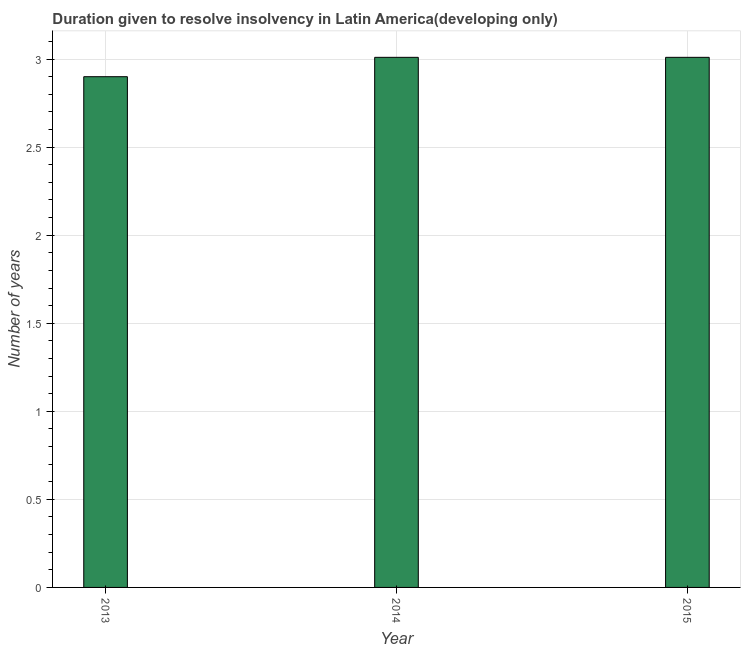Does the graph contain any zero values?
Offer a terse response. No. Does the graph contain grids?
Your answer should be very brief. Yes. What is the title of the graph?
Provide a short and direct response. Duration given to resolve insolvency in Latin America(developing only). What is the label or title of the X-axis?
Provide a succinct answer. Year. What is the label or title of the Y-axis?
Offer a terse response. Number of years. What is the number of years to resolve insolvency in 2013?
Offer a very short reply. 2.9. Across all years, what is the maximum number of years to resolve insolvency?
Your answer should be compact. 3.01. What is the sum of the number of years to resolve insolvency?
Ensure brevity in your answer.  8.92. What is the difference between the number of years to resolve insolvency in 2014 and 2015?
Offer a terse response. 0. What is the average number of years to resolve insolvency per year?
Provide a succinct answer. 2.97. What is the median number of years to resolve insolvency?
Make the answer very short. 3.01. What is the ratio of the number of years to resolve insolvency in 2013 to that in 2015?
Provide a short and direct response. 0.96. Is the difference between the number of years to resolve insolvency in 2013 and 2014 greater than the difference between any two years?
Your response must be concise. Yes. What is the difference between the highest and the second highest number of years to resolve insolvency?
Your answer should be very brief. 0. Is the sum of the number of years to resolve insolvency in 2013 and 2014 greater than the maximum number of years to resolve insolvency across all years?
Provide a succinct answer. Yes. What is the difference between the highest and the lowest number of years to resolve insolvency?
Offer a very short reply. 0.11. How many years are there in the graph?
Offer a terse response. 3. What is the difference between two consecutive major ticks on the Y-axis?
Provide a short and direct response. 0.5. What is the Number of years of 2013?
Offer a terse response. 2.9. What is the Number of years in 2014?
Your response must be concise. 3.01. What is the Number of years of 2015?
Ensure brevity in your answer.  3.01. What is the difference between the Number of years in 2013 and 2014?
Offer a very short reply. -0.11. What is the difference between the Number of years in 2013 and 2015?
Make the answer very short. -0.11. What is the ratio of the Number of years in 2014 to that in 2015?
Provide a short and direct response. 1. 